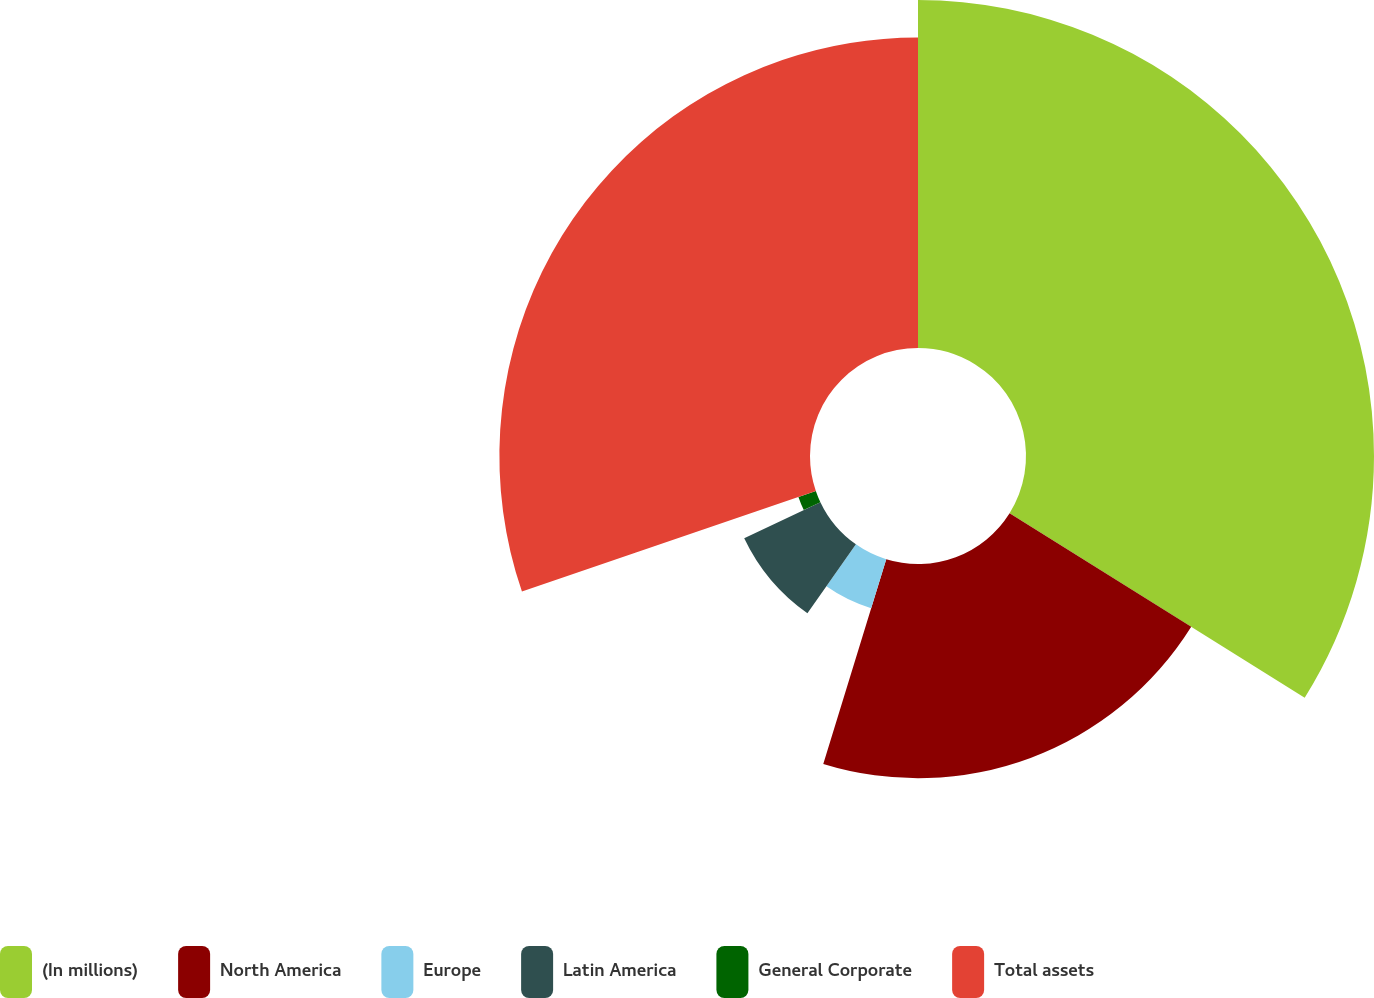Convert chart to OTSL. <chart><loc_0><loc_0><loc_500><loc_500><pie_chart><fcel>(In millions)<fcel>North America<fcel>Europe<fcel>Latin America<fcel>General Corporate<fcel>Total assets<nl><fcel>33.89%<fcel>20.86%<fcel>5.0%<fcel>8.21%<fcel>1.79%<fcel>30.25%<nl></chart> 